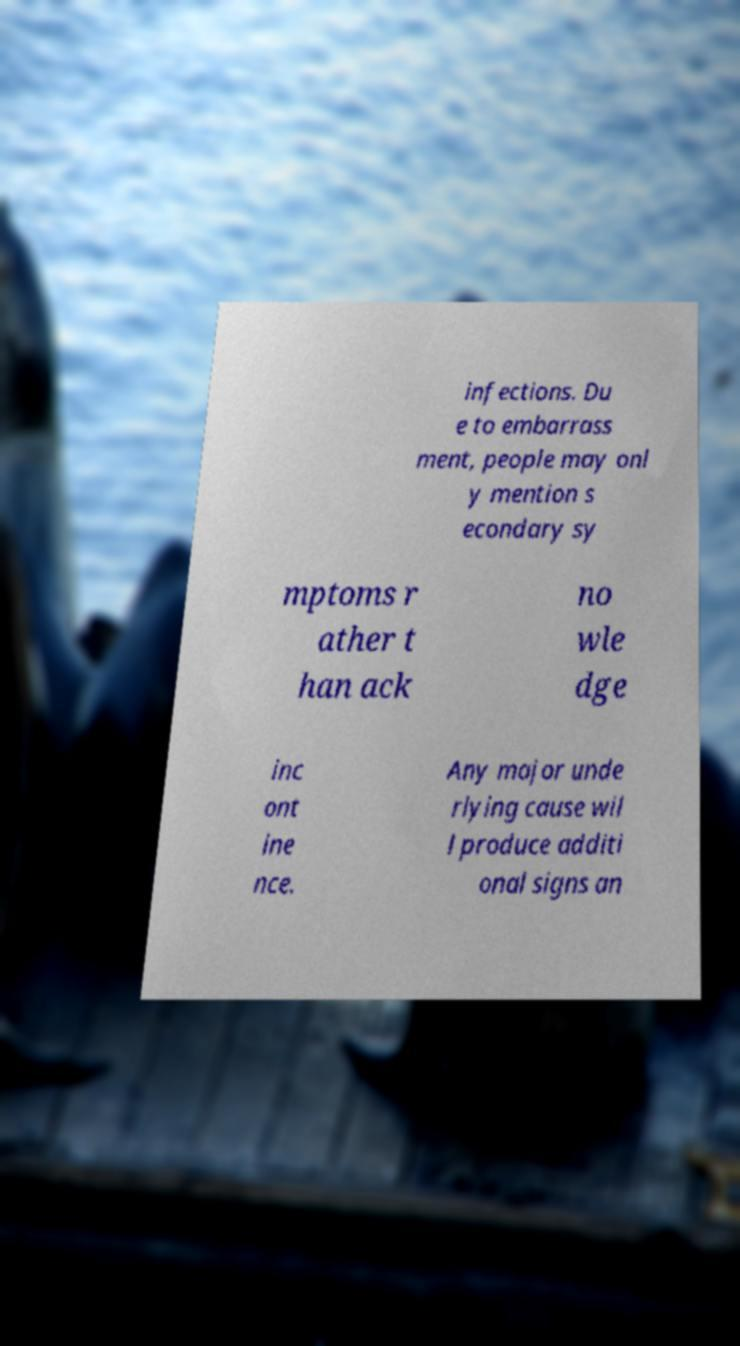Could you assist in decoding the text presented in this image and type it out clearly? infections. Du e to embarrass ment, people may onl y mention s econdary sy mptoms r ather t han ack no wle dge inc ont ine nce. Any major unde rlying cause wil l produce additi onal signs an 